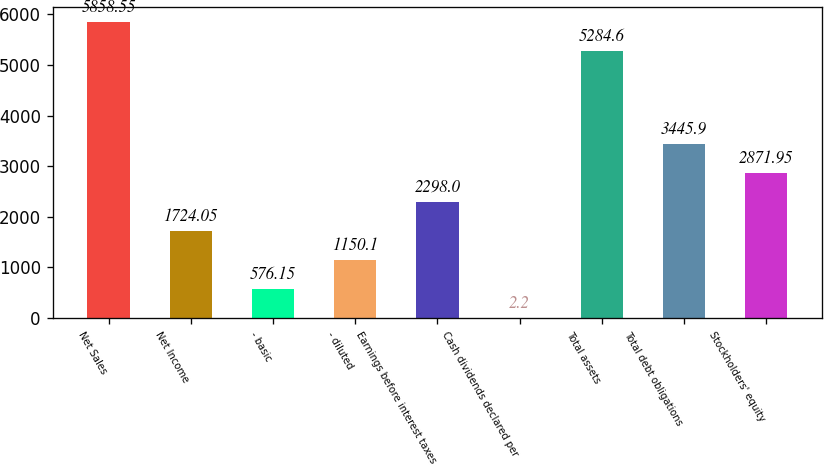Convert chart. <chart><loc_0><loc_0><loc_500><loc_500><bar_chart><fcel>Net Sales<fcel>Net Income<fcel>- basic<fcel>- diluted<fcel>Earnings before interest taxes<fcel>Cash dividends declared per<fcel>Total assets<fcel>Total debt obligations<fcel>Stockholders' equity<nl><fcel>5858.55<fcel>1724.05<fcel>576.15<fcel>1150.1<fcel>2298<fcel>2.2<fcel>5284.6<fcel>3445.9<fcel>2871.95<nl></chart> 